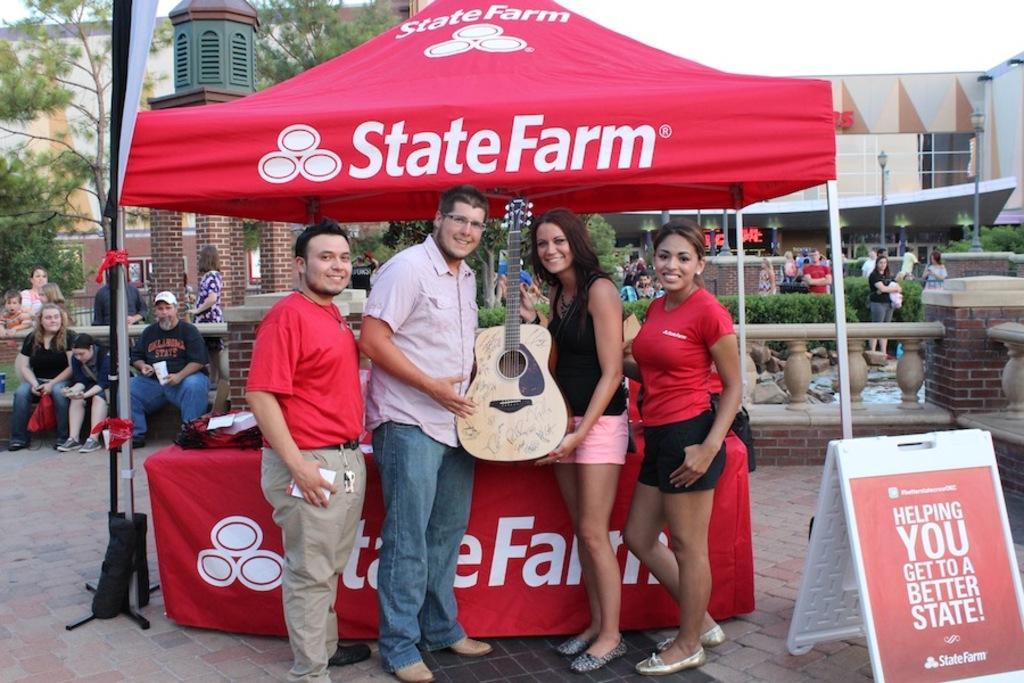In one or two sentences, can you explain what this image depicts? In this image I can see number of people around this place. Here I can see four people and two of them are holding a guitar. In the background I can see number of trees and a building. 